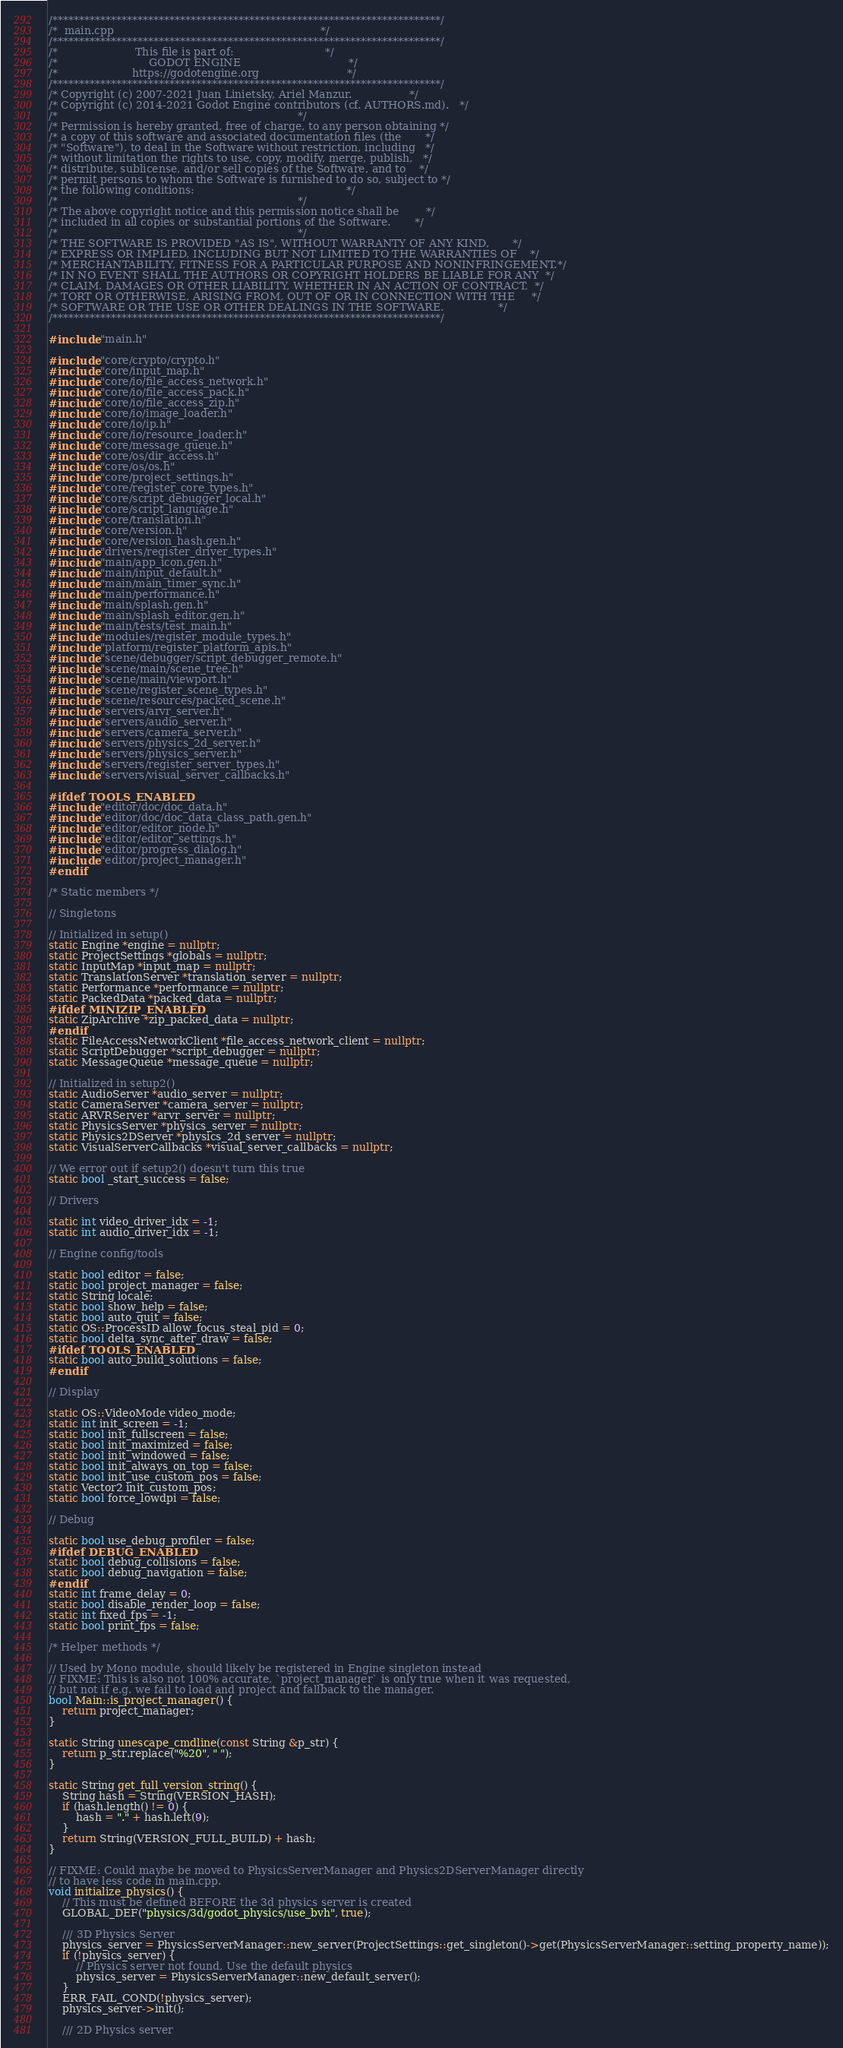Convert code to text. <code><loc_0><loc_0><loc_500><loc_500><_C++_>/*************************************************************************/
/*  main.cpp                                                             */
/*************************************************************************/
/*                       This file is part of:                           */
/*                           GODOT ENGINE                                */
/*                      https://godotengine.org                          */
/*************************************************************************/
/* Copyright (c) 2007-2021 Juan Linietsky, Ariel Manzur.                 */
/* Copyright (c) 2014-2021 Godot Engine contributors (cf. AUTHORS.md).   */
/*                                                                       */
/* Permission is hereby granted, free of charge, to any person obtaining */
/* a copy of this software and associated documentation files (the       */
/* "Software"), to deal in the Software without restriction, including   */
/* without limitation the rights to use, copy, modify, merge, publish,   */
/* distribute, sublicense, and/or sell copies of the Software, and to    */
/* permit persons to whom the Software is furnished to do so, subject to */
/* the following conditions:                                             */
/*                                                                       */
/* The above copyright notice and this permission notice shall be        */
/* included in all copies or substantial portions of the Software.       */
/*                                                                       */
/* THE SOFTWARE IS PROVIDED "AS IS", WITHOUT WARRANTY OF ANY KIND,       */
/* EXPRESS OR IMPLIED, INCLUDING BUT NOT LIMITED TO THE WARRANTIES OF    */
/* MERCHANTABILITY, FITNESS FOR A PARTICULAR PURPOSE AND NONINFRINGEMENT.*/
/* IN NO EVENT SHALL THE AUTHORS OR COPYRIGHT HOLDERS BE LIABLE FOR ANY  */
/* CLAIM, DAMAGES OR OTHER LIABILITY, WHETHER IN AN ACTION OF CONTRACT,  */
/* TORT OR OTHERWISE, ARISING FROM, OUT OF OR IN CONNECTION WITH THE     */
/* SOFTWARE OR THE USE OR OTHER DEALINGS IN THE SOFTWARE.                */
/*************************************************************************/

#include "main.h"

#include "core/crypto/crypto.h"
#include "core/input_map.h"
#include "core/io/file_access_network.h"
#include "core/io/file_access_pack.h"
#include "core/io/file_access_zip.h"
#include "core/io/image_loader.h"
#include "core/io/ip.h"
#include "core/io/resource_loader.h"
#include "core/message_queue.h"
#include "core/os/dir_access.h"
#include "core/os/os.h"
#include "core/project_settings.h"
#include "core/register_core_types.h"
#include "core/script_debugger_local.h"
#include "core/script_language.h"
#include "core/translation.h"
#include "core/version.h"
#include "core/version_hash.gen.h"
#include "drivers/register_driver_types.h"
#include "main/app_icon.gen.h"
#include "main/input_default.h"
#include "main/main_timer_sync.h"
#include "main/performance.h"
#include "main/splash.gen.h"
#include "main/splash_editor.gen.h"
#include "main/tests/test_main.h"
#include "modules/register_module_types.h"
#include "platform/register_platform_apis.h"
#include "scene/debugger/script_debugger_remote.h"
#include "scene/main/scene_tree.h"
#include "scene/main/viewport.h"
#include "scene/register_scene_types.h"
#include "scene/resources/packed_scene.h"
#include "servers/arvr_server.h"
#include "servers/audio_server.h"
#include "servers/camera_server.h"
#include "servers/physics_2d_server.h"
#include "servers/physics_server.h"
#include "servers/register_server_types.h"
#include "servers/visual_server_callbacks.h"

#ifdef TOOLS_ENABLED
#include "editor/doc/doc_data.h"
#include "editor/doc/doc_data_class_path.gen.h"
#include "editor/editor_node.h"
#include "editor/editor_settings.h"
#include "editor/progress_dialog.h"
#include "editor/project_manager.h"
#endif

/* Static members */

// Singletons

// Initialized in setup()
static Engine *engine = nullptr;
static ProjectSettings *globals = nullptr;
static InputMap *input_map = nullptr;
static TranslationServer *translation_server = nullptr;
static Performance *performance = nullptr;
static PackedData *packed_data = nullptr;
#ifdef MINIZIP_ENABLED
static ZipArchive *zip_packed_data = nullptr;
#endif
static FileAccessNetworkClient *file_access_network_client = nullptr;
static ScriptDebugger *script_debugger = nullptr;
static MessageQueue *message_queue = nullptr;

// Initialized in setup2()
static AudioServer *audio_server = nullptr;
static CameraServer *camera_server = nullptr;
static ARVRServer *arvr_server = nullptr;
static PhysicsServer *physics_server = nullptr;
static Physics2DServer *physics_2d_server = nullptr;
static VisualServerCallbacks *visual_server_callbacks = nullptr;

// We error out if setup2() doesn't turn this true
static bool _start_success = false;

// Drivers

static int video_driver_idx = -1;
static int audio_driver_idx = -1;

// Engine config/tools

static bool editor = false;
static bool project_manager = false;
static String locale;
static bool show_help = false;
static bool auto_quit = false;
static OS::ProcessID allow_focus_steal_pid = 0;
static bool delta_sync_after_draw = false;
#ifdef TOOLS_ENABLED
static bool auto_build_solutions = false;
#endif

// Display

static OS::VideoMode video_mode;
static int init_screen = -1;
static bool init_fullscreen = false;
static bool init_maximized = false;
static bool init_windowed = false;
static bool init_always_on_top = false;
static bool init_use_custom_pos = false;
static Vector2 init_custom_pos;
static bool force_lowdpi = false;

// Debug

static bool use_debug_profiler = false;
#ifdef DEBUG_ENABLED
static bool debug_collisions = false;
static bool debug_navigation = false;
#endif
static int frame_delay = 0;
static bool disable_render_loop = false;
static int fixed_fps = -1;
static bool print_fps = false;

/* Helper methods */

// Used by Mono module, should likely be registered in Engine singleton instead
// FIXME: This is also not 100% accurate, `project_manager` is only true when it was requested,
// but not if e.g. we fail to load and project and fallback to the manager.
bool Main::is_project_manager() {
	return project_manager;
}

static String unescape_cmdline(const String &p_str) {
	return p_str.replace("%20", " ");
}

static String get_full_version_string() {
	String hash = String(VERSION_HASH);
	if (hash.length() != 0) {
		hash = "." + hash.left(9);
	}
	return String(VERSION_FULL_BUILD) + hash;
}

// FIXME: Could maybe be moved to PhysicsServerManager and Physics2DServerManager directly
// to have less code in main.cpp.
void initialize_physics() {
	// This must be defined BEFORE the 3d physics server is created
	GLOBAL_DEF("physics/3d/godot_physics/use_bvh", true);

	/// 3D Physics Server
	physics_server = PhysicsServerManager::new_server(ProjectSettings::get_singleton()->get(PhysicsServerManager::setting_property_name));
	if (!physics_server) {
		// Physics server not found, Use the default physics
		physics_server = PhysicsServerManager::new_default_server();
	}
	ERR_FAIL_COND(!physics_server);
	physics_server->init();

	/// 2D Physics server</code> 